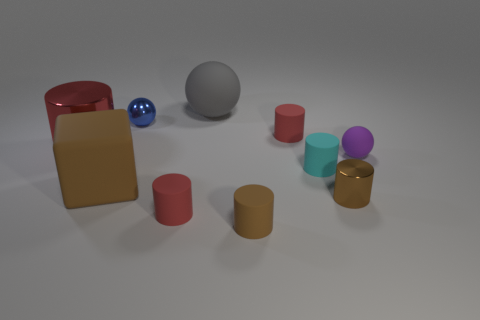What is the function of the red cube in the image? The red cube doesn't have an obvious function within the image's context. It seems to be a simple geometric shape placed there, likely for visual or artistic purposes to add color and variety to the scene. 